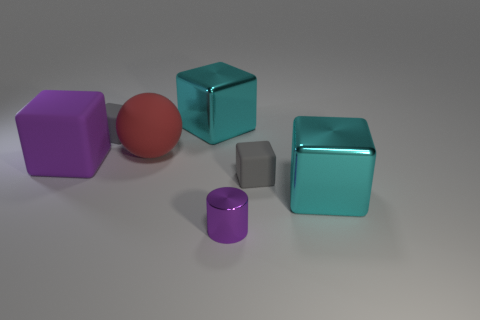How many other things are the same color as the small metallic cylinder?
Offer a very short reply. 1. How many other objects are there of the same material as the small cylinder?
Ensure brevity in your answer.  2. There is a sphere that is the same size as the purple block; what material is it?
Your answer should be compact. Rubber. There is a matte cube behind the red rubber thing; is it the same color as the small block that is in front of the purple block?
Your response must be concise. Yes. Is there a tiny gray matte thing that has the same shape as the red matte thing?
Provide a short and direct response. No. There is a purple matte thing that is the same size as the matte ball; what is its shape?
Provide a succinct answer. Cube. What number of things are the same color as the big matte ball?
Your answer should be very brief. 0. There is a cyan cube behind the large purple block; what is its size?
Your answer should be compact. Large. What number of metallic objects are the same size as the red ball?
Offer a very short reply. 2. There is a big object that is the same material as the ball; what color is it?
Offer a very short reply. Purple. 